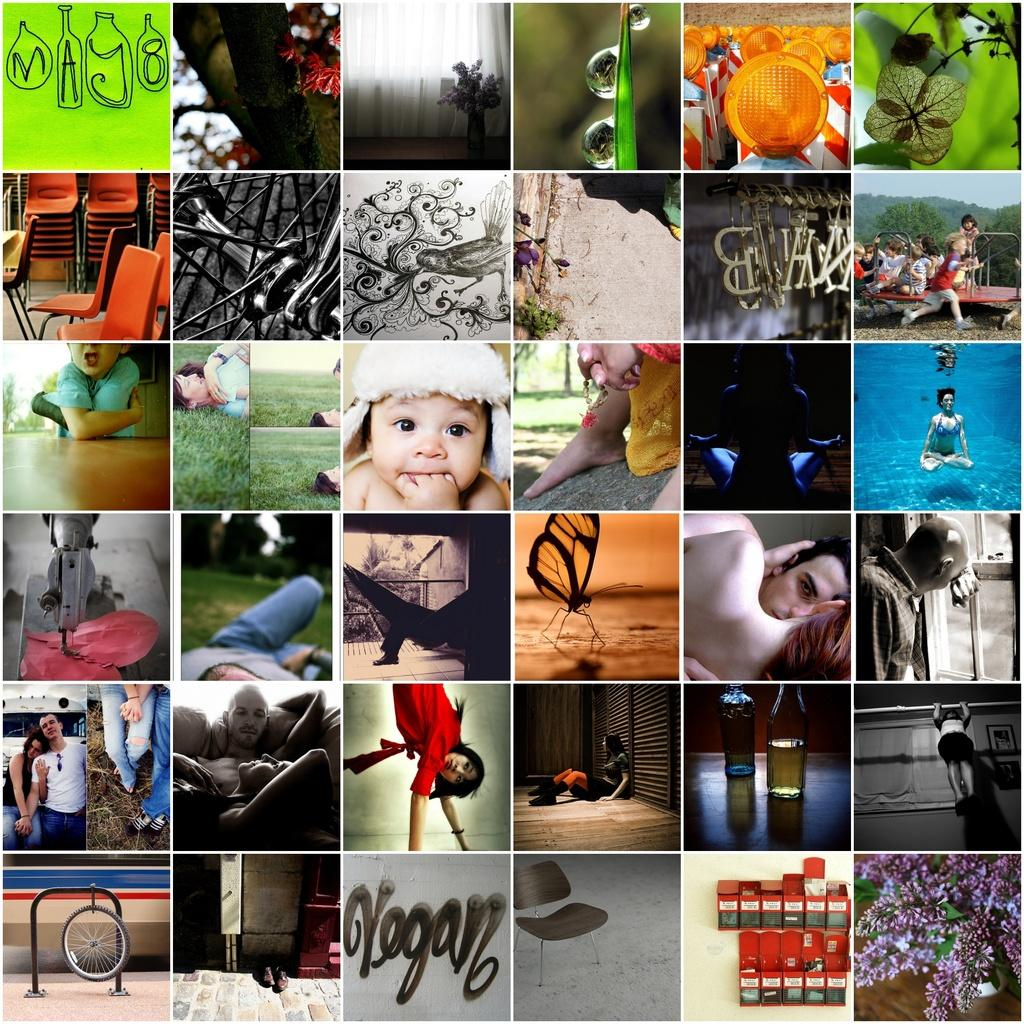What type of content is present in the image? The image contains text. What theme is depicted in the image? The image contains elements related to nature and family. Are there any objects in the image that resemble machines? Yes, the image contains objects that resemble machines. What is the person in the middle of the image writing about? There is no person present in the image, so it is not possible to determine what they might be writing about. 